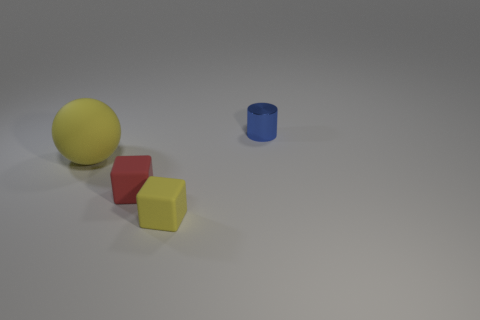There is a yellow object behind the red rubber cube; is its size the same as the small cylinder?
Offer a very short reply. No. How many things are tiny blue cylinders or matte cubes?
Offer a very short reply. 3. There is a thing that is the same color as the big sphere; what shape is it?
Ensure brevity in your answer.  Cube. There is a thing that is on the right side of the tiny red object and left of the small metallic object; what size is it?
Offer a very short reply. Small. How many tiny blue things are there?
Your answer should be very brief. 1. What number of blocks are tiny red things or blue metallic objects?
Keep it short and to the point. 1. How many tiny yellow rubber blocks are to the right of the yellow matte thing that is behind the tiny rubber cube that is right of the red matte object?
Make the answer very short. 1. There is a metal object that is the same size as the red matte object; what is its color?
Make the answer very short. Blue. How many other things are there of the same color as the tiny metallic thing?
Provide a short and direct response. 0. Are there more big matte things that are left of the rubber sphere than purple rubber cylinders?
Offer a very short reply. No. 